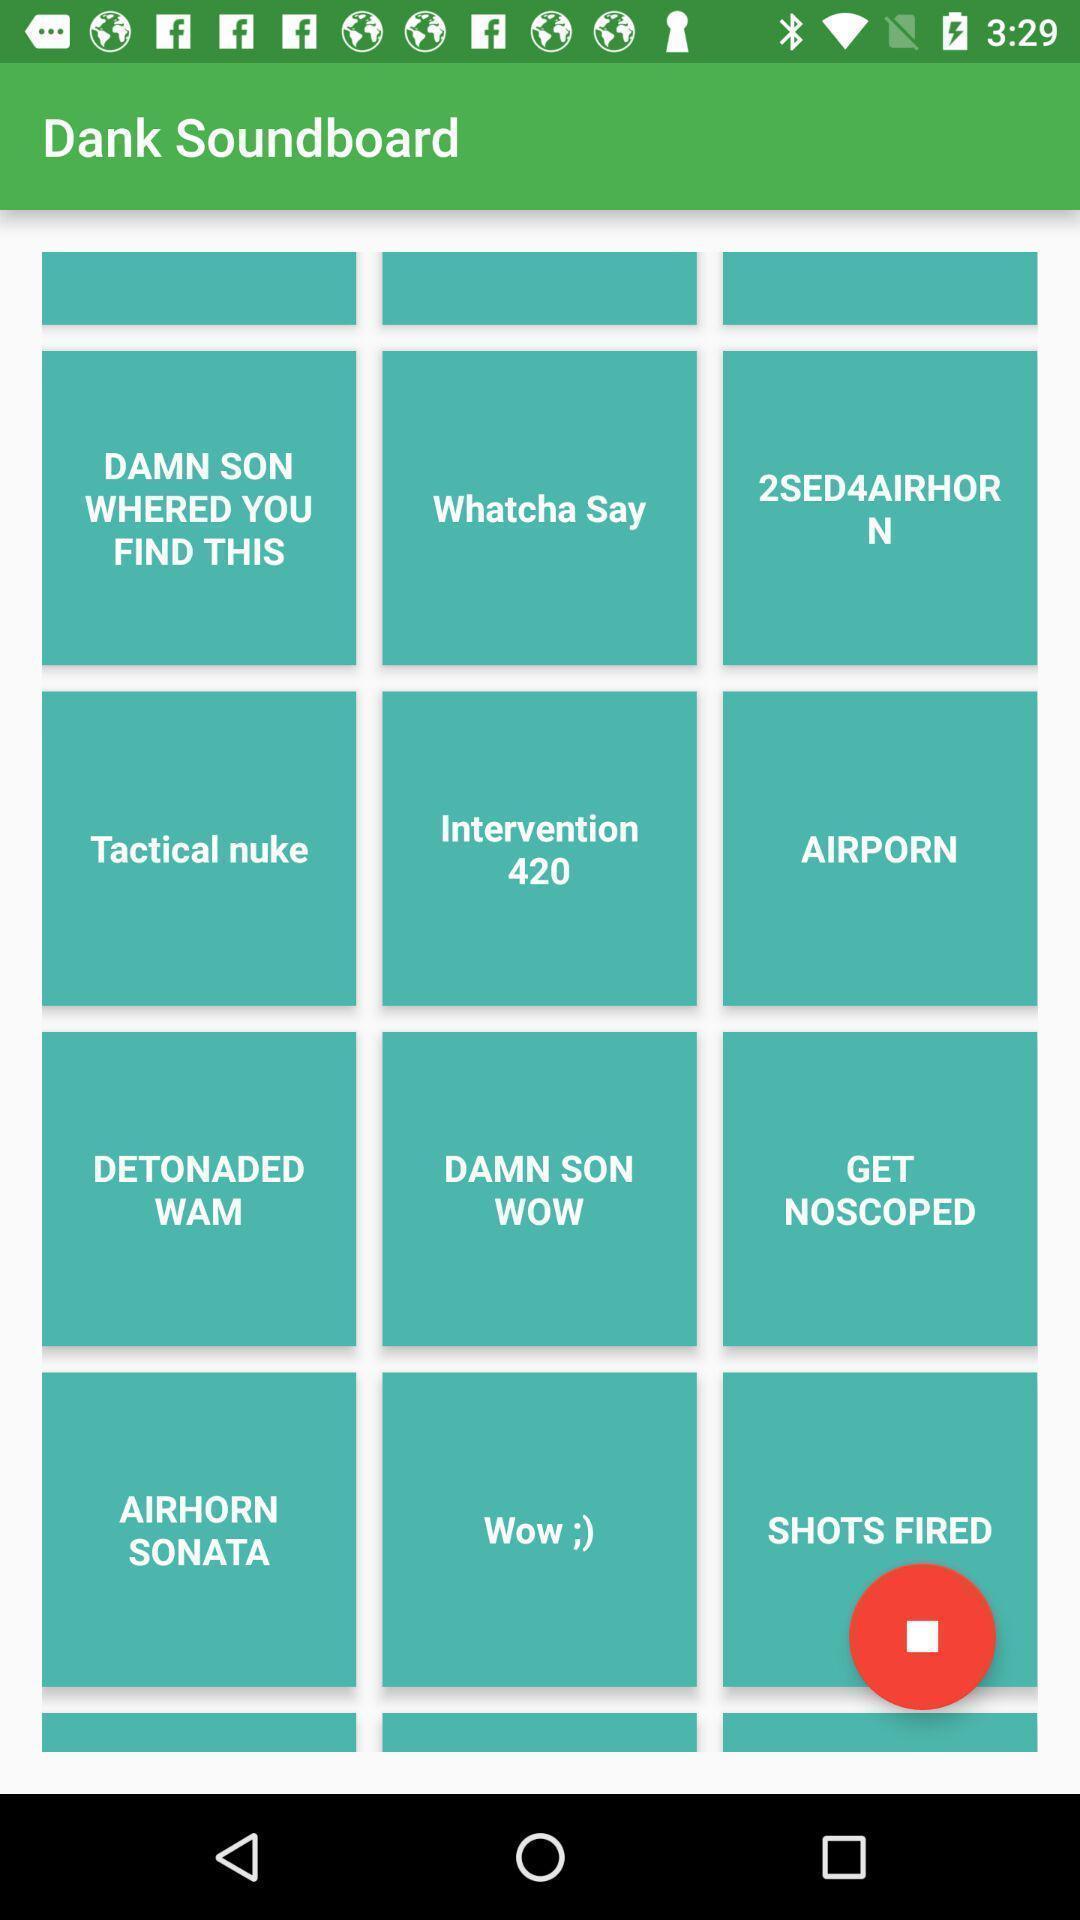What is the overall content of this screenshot? Page displaying the various options. 